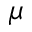<formula> <loc_0><loc_0><loc_500><loc_500>\mu</formula> 